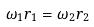Convert formula to latex. <formula><loc_0><loc_0><loc_500><loc_500>\omega _ { 1 } r _ { 1 } = \omega _ { 2 } r _ { 2 }</formula> 